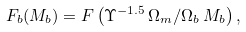Convert formula to latex. <formula><loc_0><loc_0><loc_500><loc_500>F _ { b } ( M _ { b } ) = F \left ( \Upsilon ^ { - 1 . 5 } \, \Omega _ { m } / \Omega _ { b } \, M _ { b } \right ) ,</formula> 